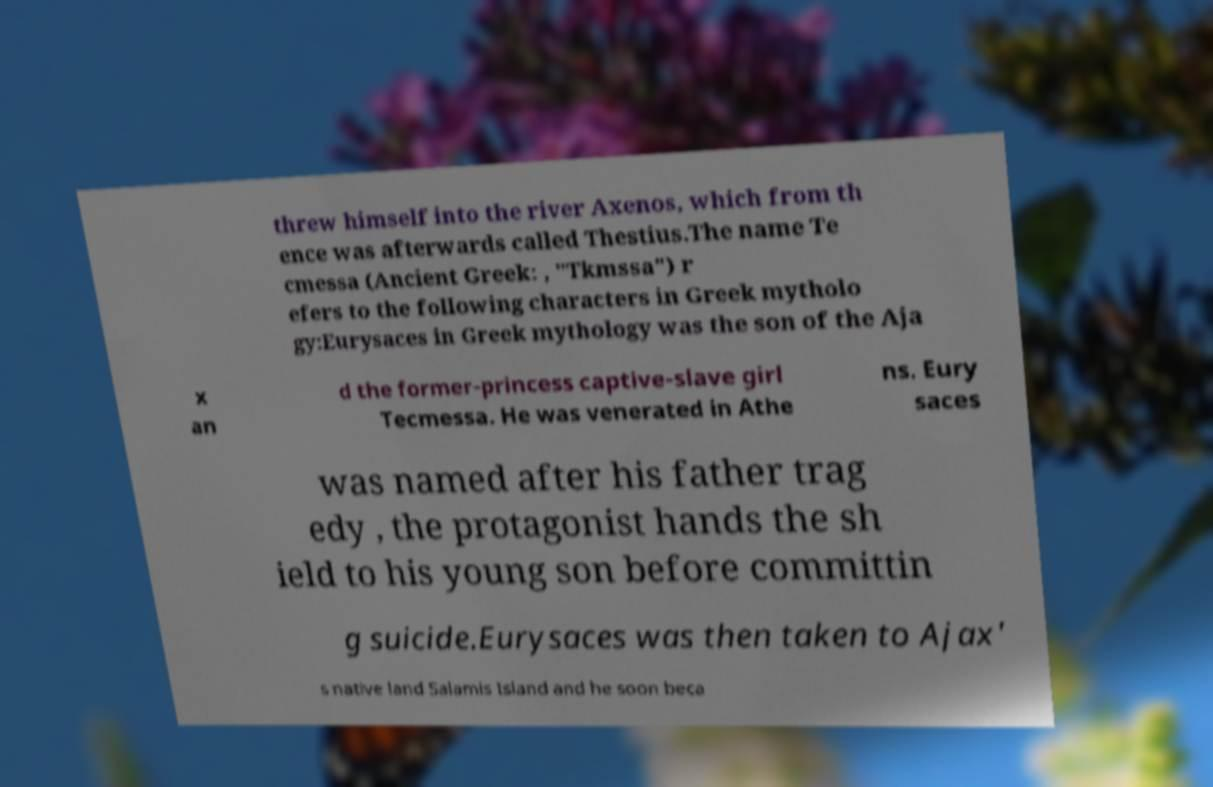Can you read and provide the text displayed in the image?This photo seems to have some interesting text. Can you extract and type it out for me? threw himself into the river Axenos, which from th ence was afterwards called Thestius.The name Te cmessa (Ancient Greek: , "Tkmssa") r efers to the following characters in Greek mytholo gy:Eurysaces in Greek mythology was the son of the Aja x an d the former-princess captive-slave girl Tecmessa. He was venerated in Athe ns. Eury saces was named after his father trag edy , the protagonist hands the sh ield to his young son before committin g suicide.Eurysaces was then taken to Ajax' s native land Salamis Island and he soon beca 